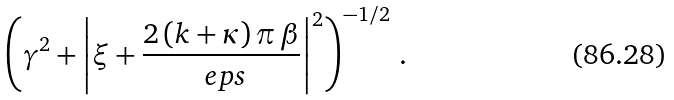<formula> <loc_0><loc_0><loc_500><loc_500>\left ( \gamma ^ { 2 } + \left | \xi + \frac { 2 \, ( k + \kappa ) \, \pi \, \beta } { \ e p s } \right | ^ { 2 } \right ) ^ { - 1 / 2 } \, .</formula> 